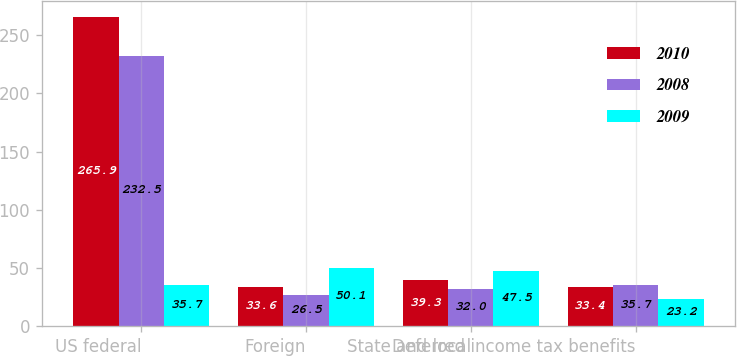Convert chart to OTSL. <chart><loc_0><loc_0><loc_500><loc_500><stacked_bar_chart><ecel><fcel>US federal<fcel>Foreign<fcel>State and local<fcel>Deferred income tax benefits<nl><fcel>2010<fcel>265.9<fcel>33.6<fcel>39.3<fcel>33.4<nl><fcel>2008<fcel>232.5<fcel>26.5<fcel>32<fcel>35.7<nl><fcel>2009<fcel>35.7<fcel>50.1<fcel>47.5<fcel>23.2<nl></chart> 